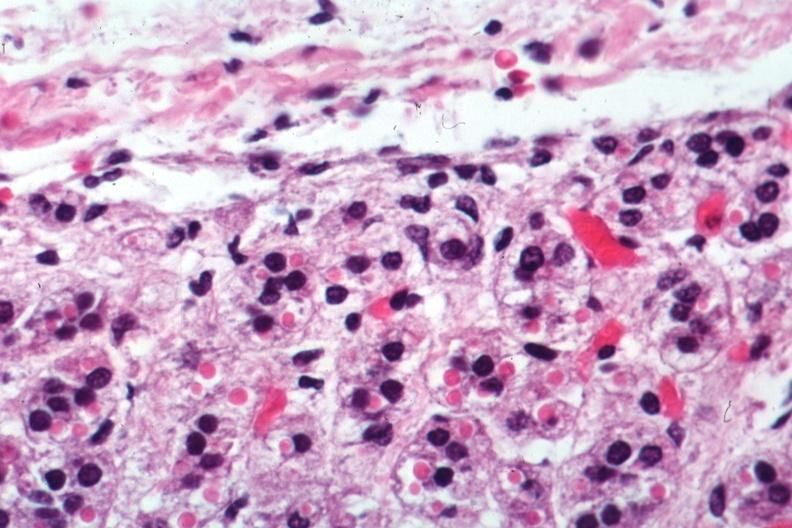s slide present?
Answer the question using a single word or phrase. No 